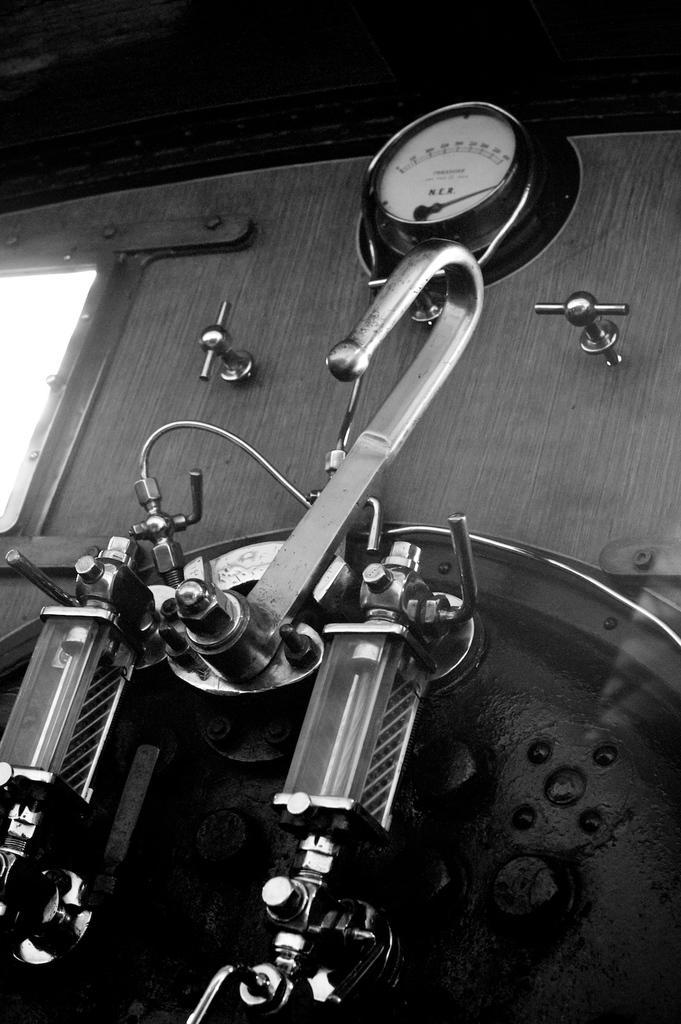Could you give a brief overview of what you see in this image? In the image we can see a machine and a meter reading, and the image is black and white in color. 